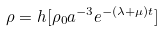<formula> <loc_0><loc_0><loc_500><loc_500>\rho = h [ \rho _ { 0 } a ^ { - 3 } e ^ { - ( \lambda + \mu ) t } ]</formula> 